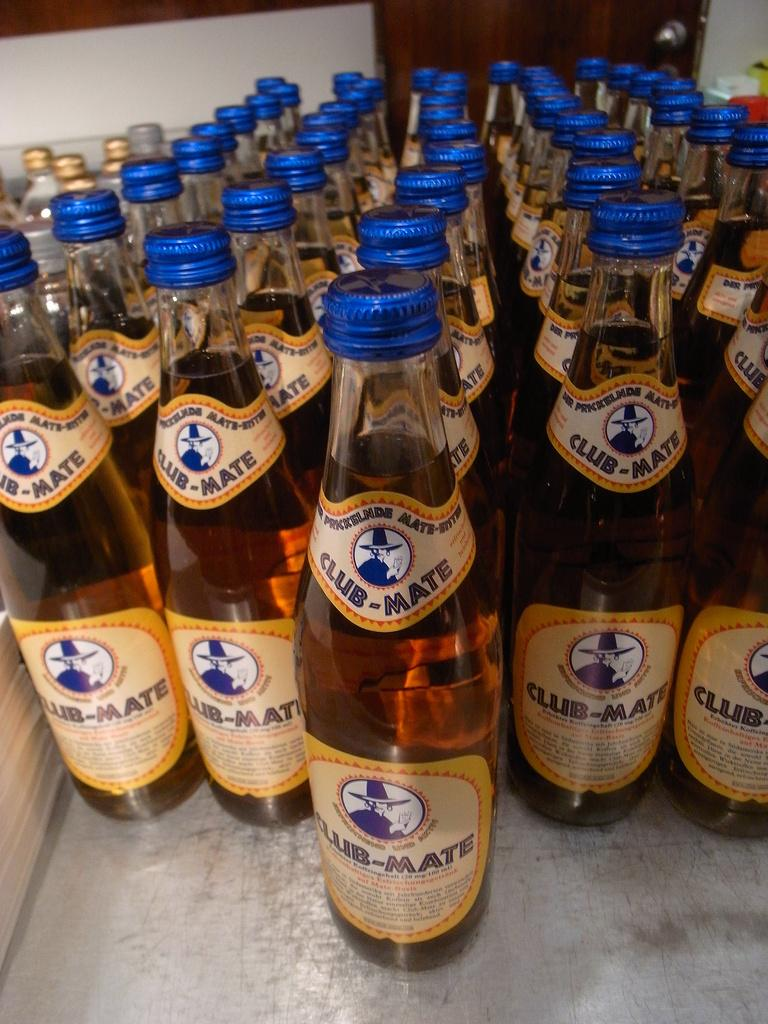Provide a one-sentence caption for the provided image. A table full of bottles of Club-Mate beer. 